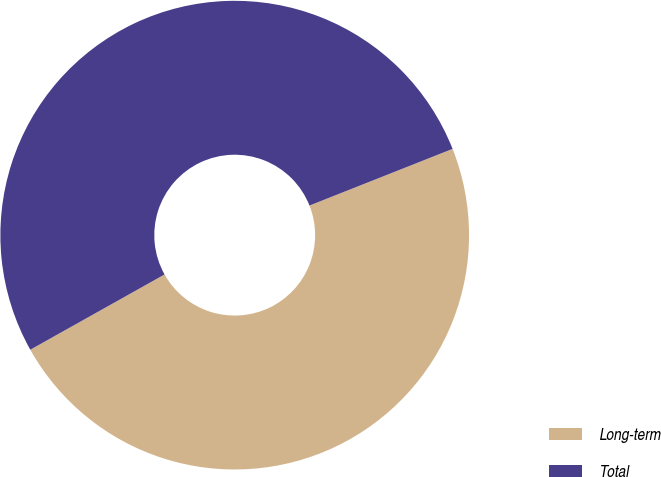Convert chart to OTSL. <chart><loc_0><loc_0><loc_500><loc_500><pie_chart><fcel>Long-term<fcel>Total<nl><fcel>47.87%<fcel>52.13%<nl></chart> 